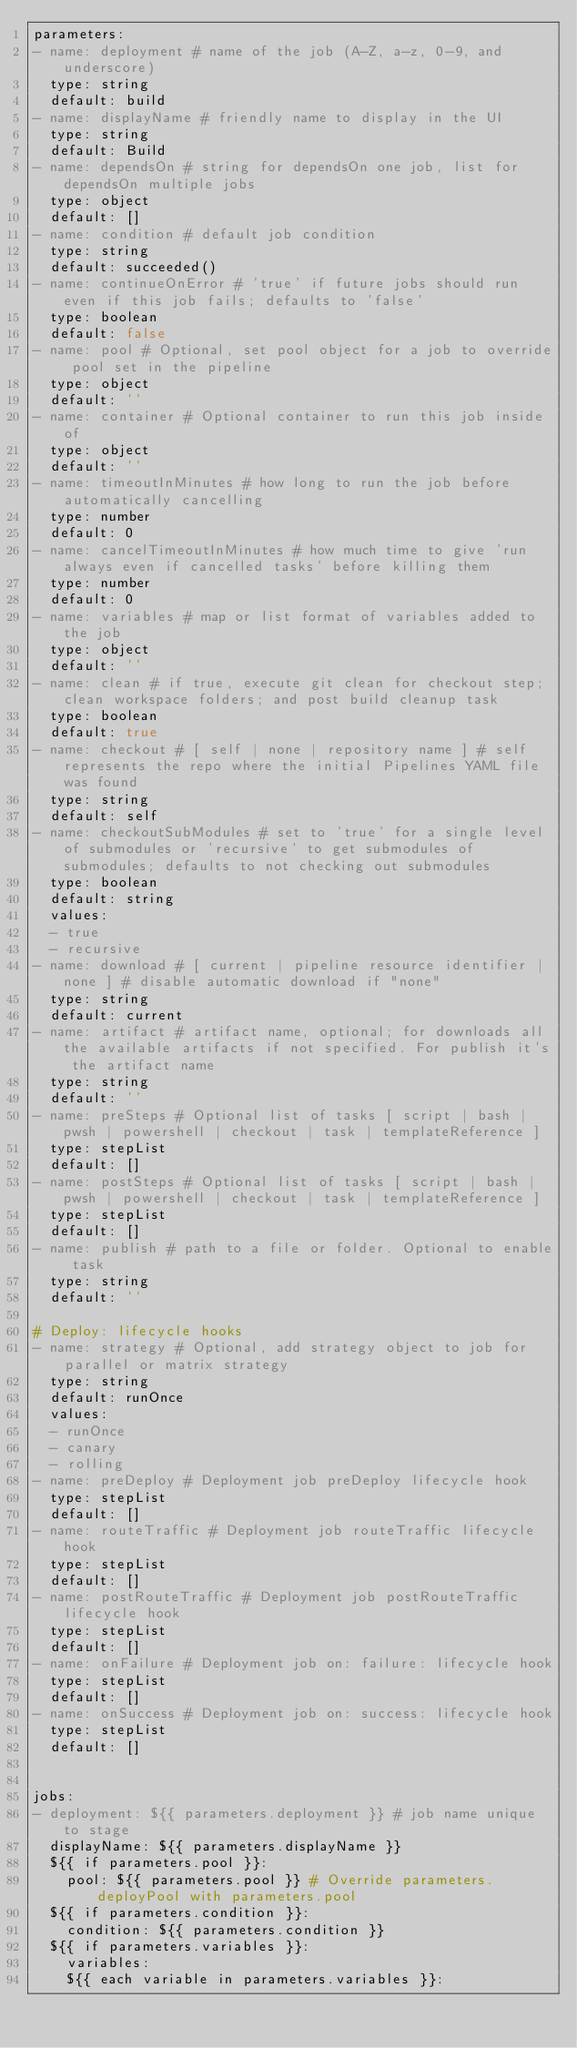<code> <loc_0><loc_0><loc_500><loc_500><_YAML_>parameters:
- name: deployment # name of the job (A-Z, a-z, 0-9, and underscore)
  type: string
  default: build
- name: displayName # friendly name to display in the UI
  type: string
  default: Build
- name: dependsOn # string for dependsOn one job, list for dependsOn multiple jobs
  type: object
  default: []
- name: condition # default job condition
  type: string
  default: succeeded()
- name: continueOnError # 'true' if future jobs should run even if this job fails; defaults to 'false'
  type: boolean
  default: false
- name: pool # Optional, set pool object for a job to override pool set in the pipeline
  type: object
  default: ''
- name: container # Optional container to run this job inside of
  type: object
  default: ''
- name: timeoutInMinutes # how long to run the job before automatically cancelling
  type: number
  default: 0
- name: cancelTimeoutInMinutes # how much time to give 'run always even if cancelled tasks' before killing them
  type: number
  default: 0
- name: variables # map or list format of variables added to the job
  type: object
  default: ''
- name: clean # if true, execute git clean for checkout step; clean workspace folders; and post build cleanup task
  type: boolean
  default: true
- name: checkout # [ self | none | repository name ] # self represents the repo where the initial Pipelines YAML file was found
  type: string
  default: self
- name: checkoutSubModules # set to 'true' for a single level of submodules or 'recursive' to get submodules of submodules; defaults to not checking out submodules
  type: boolean
  default: string
  values:
  - true
  - recursive
- name: download # [ current | pipeline resource identifier | none ] # disable automatic download if "none"
  type: string
  default: current
- name: artifact # artifact name, optional; for downloads all the available artifacts if not specified. For publish it's the artifact name
  type: string
  default: ''
- name: preSteps # Optional list of tasks [ script | bash | pwsh | powershell | checkout | task | templateReference ]
  type: stepList
  default: []
- name: postSteps # Optional list of tasks [ script | bash | pwsh | powershell | checkout | task | templateReference ]
  type: stepList
  default: []
- name: publish # path to a file or folder. Optional to enable task
  type: string
  default: ''

# Deploy: lifecycle hooks
- name: strategy # Optional, add strategy object to job for parallel or matrix strategy
  type: string
  default: runOnce
  values:
  - runOnce
  - canary
  - rolling
- name: preDeploy # Deployment job preDeploy lifecycle hook
  type: stepList
  default: []
- name: routeTraffic # Deployment job routeTraffic lifecycle hook
  type: stepList
  default: []
- name: postRouteTraffic # Deployment job postRouteTraffic lifecycle hook
  type: stepList
  default: []
- name: onFailure # Deployment job on: failure: lifecycle hook
  type: stepList
  default: []
- name: onSuccess # Deployment job on: success: lifecycle hook
  type: stepList
  default: []


jobs:
- deployment: ${{ parameters.deployment }} # job name unique to stage
  displayName: ${{ parameters.displayName }}
  ${{ if parameters.pool }}:
    pool: ${{ parameters.pool }} # Override parameters.deployPool with parameters.pool
  ${{ if parameters.condition }}:
    condition: ${{ parameters.condition }}
  ${{ if parameters.variables }}:
    variables:
    ${{ each variable in parameters.variables }}:</code> 